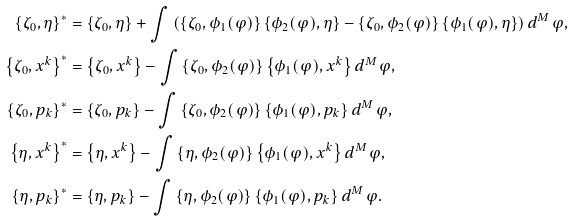<formula> <loc_0><loc_0><loc_500><loc_500>\left \{ { \zeta _ { 0 } , \eta } \right \} ^ { * } & = \left \{ { \zeta _ { 0 } , \eta } \right \} + \int { \left ( { \left \{ { \zeta _ { 0 } , \phi _ { 1 } ( \varphi ) } \right \} \left \{ { \phi _ { 2 } ( \varphi ) , \eta } \right \} - \left \{ { \zeta _ { 0 } , \phi _ { 2 } ( \varphi ) } \right \} \left \{ { \phi _ { 1 } ( \varphi ) , \eta } \right \} } \right ) d ^ { M } \varphi } , \\ \left \{ { \zeta _ { 0 } , x ^ { k } } \right \} ^ { * } & = \left \{ { \zeta _ { 0 } , x ^ { k } } \right \} - \int { \left \{ { \zeta _ { 0 } , \phi _ { 2 } ( \varphi ) } \right \} \left \{ { \phi _ { 1 } ( \varphi ) , x ^ { k } } \right \} d ^ { M } \varphi } , \\ \left \{ { \zeta _ { 0 } , p _ { k } } \right \} ^ { * } & = \left \{ { \zeta _ { 0 } , p _ { k } } \right \} - \int { \left \{ { \zeta _ { 0 } , \phi _ { 2 } ( \varphi ) } \right \} \left \{ { \phi _ { 1 } ( \varphi ) , p _ { k } } \right \} d ^ { M } \varphi } , \\ \left \{ { \eta , x ^ { k } } \right \} ^ { * } & = \left \{ { \eta , x ^ { k } } \right \} - \int { \left \{ { \eta , \phi _ { 2 } ( \varphi ) } \right \} \left \{ { \phi _ { 1 } ( \varphi ) , x ^ { k } } \right \} d ^ { M } \varphi } , \\ \left \{ { \eta , p _ { k } } \right \} ^ { * } & = \left \{ { \eta , p _ { k } } \right \} - \int { \left \{ { \eta , \phi _ { 2 } ( \varphi ) } \right \} \left \{ { \phi _ { 1 } ( \varphi ) , p _ { k } } \right \} d ^ { M } \varphi } .</formula> 